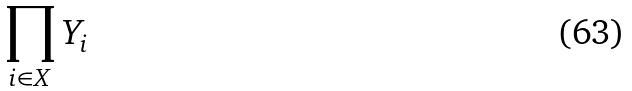<formula> <loc_0><loc_0><loc_500><loc_500>\prod _ { i \in X } Y _ { i }</formula> 